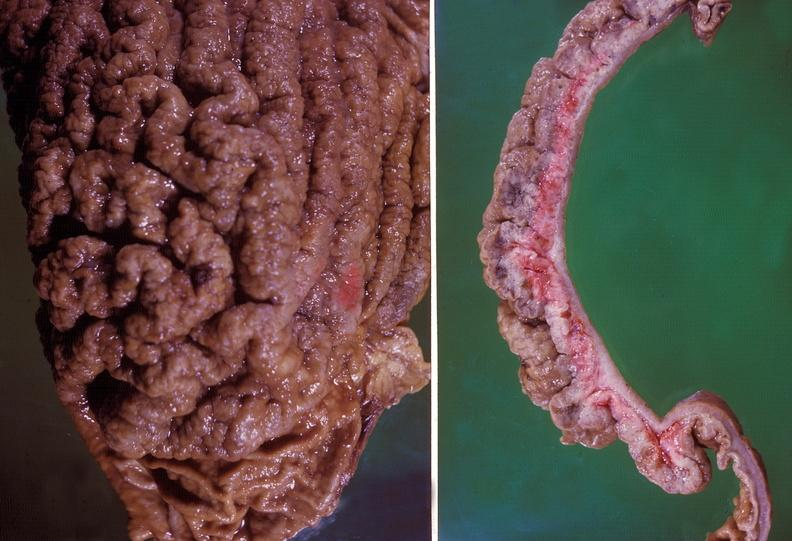what does this image show?
Answer the question using a single word or phrase. Stomach 